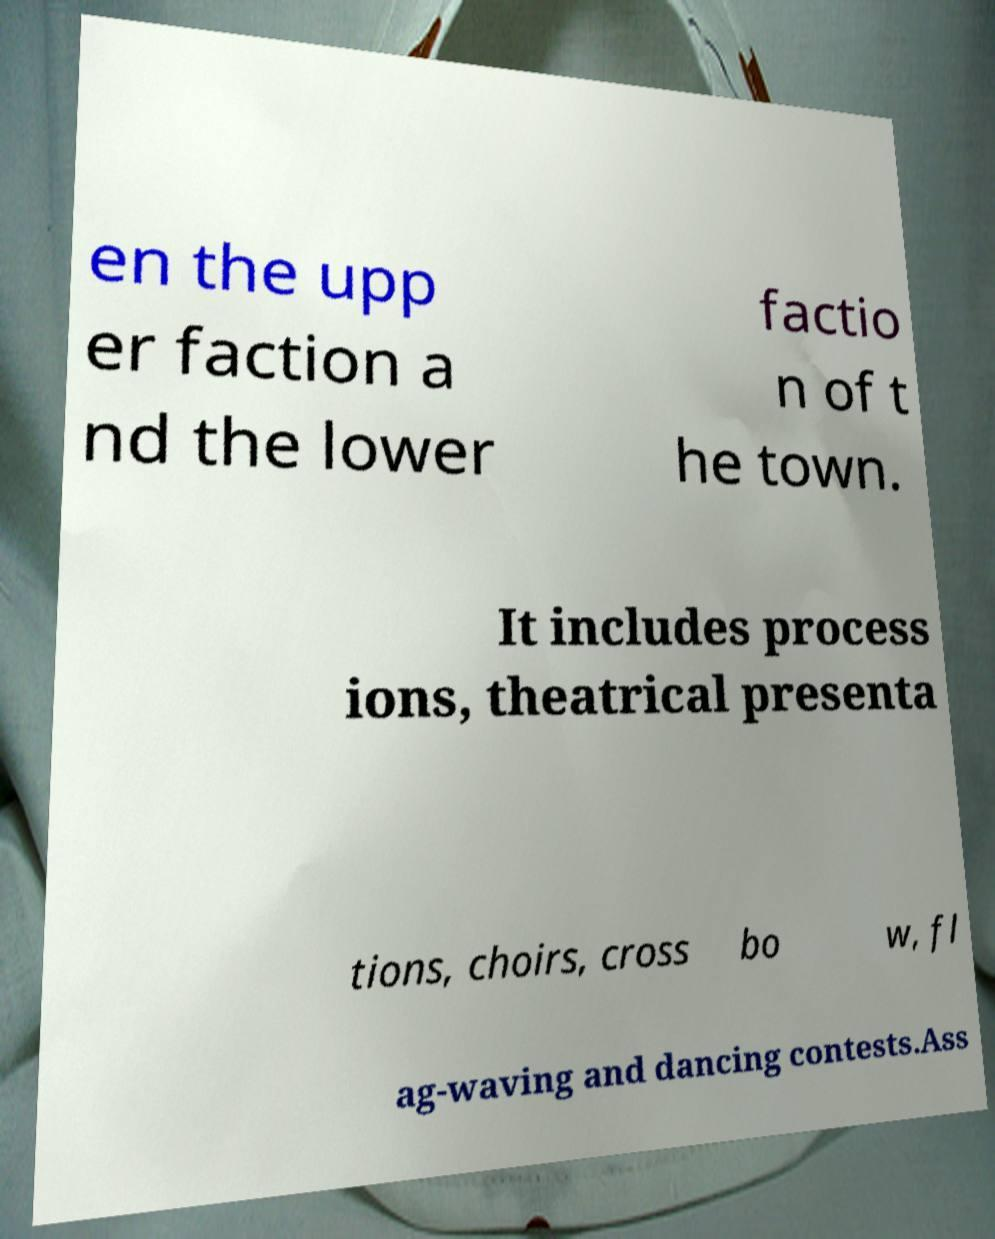Please identify and transcribe the text found in this image. en the upp er faction a nd the lower factio n of t he town. It includes process ions, theatrical presenta tions, choirs, cross bo w, fl ag-waving and dancing contests.Ass 